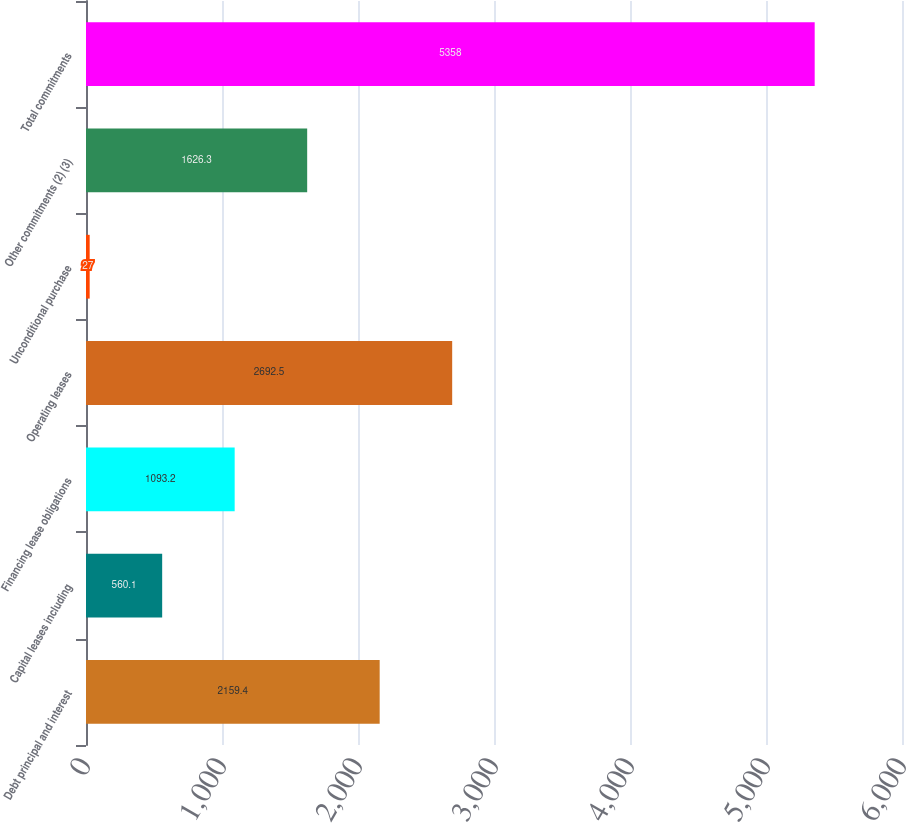Convert chart to OTSL. <chart><loc_0><loc_0><loc_500><loc_500><bar_chart><fcel>Debt principal and interest<fcel>Capital leases including<fcel>Financing lease obligations<fcel>Operating leases<fcel>Unconditional purchase<fcel>Other commitments (2) (3)<fcel>Total commitments<nl><fcel>2159.4<fcel>560.1<fcel>1093.2<fcel>2692.5<fcel>27<fcel>1626.3<fcel>5358<nl></chart> 